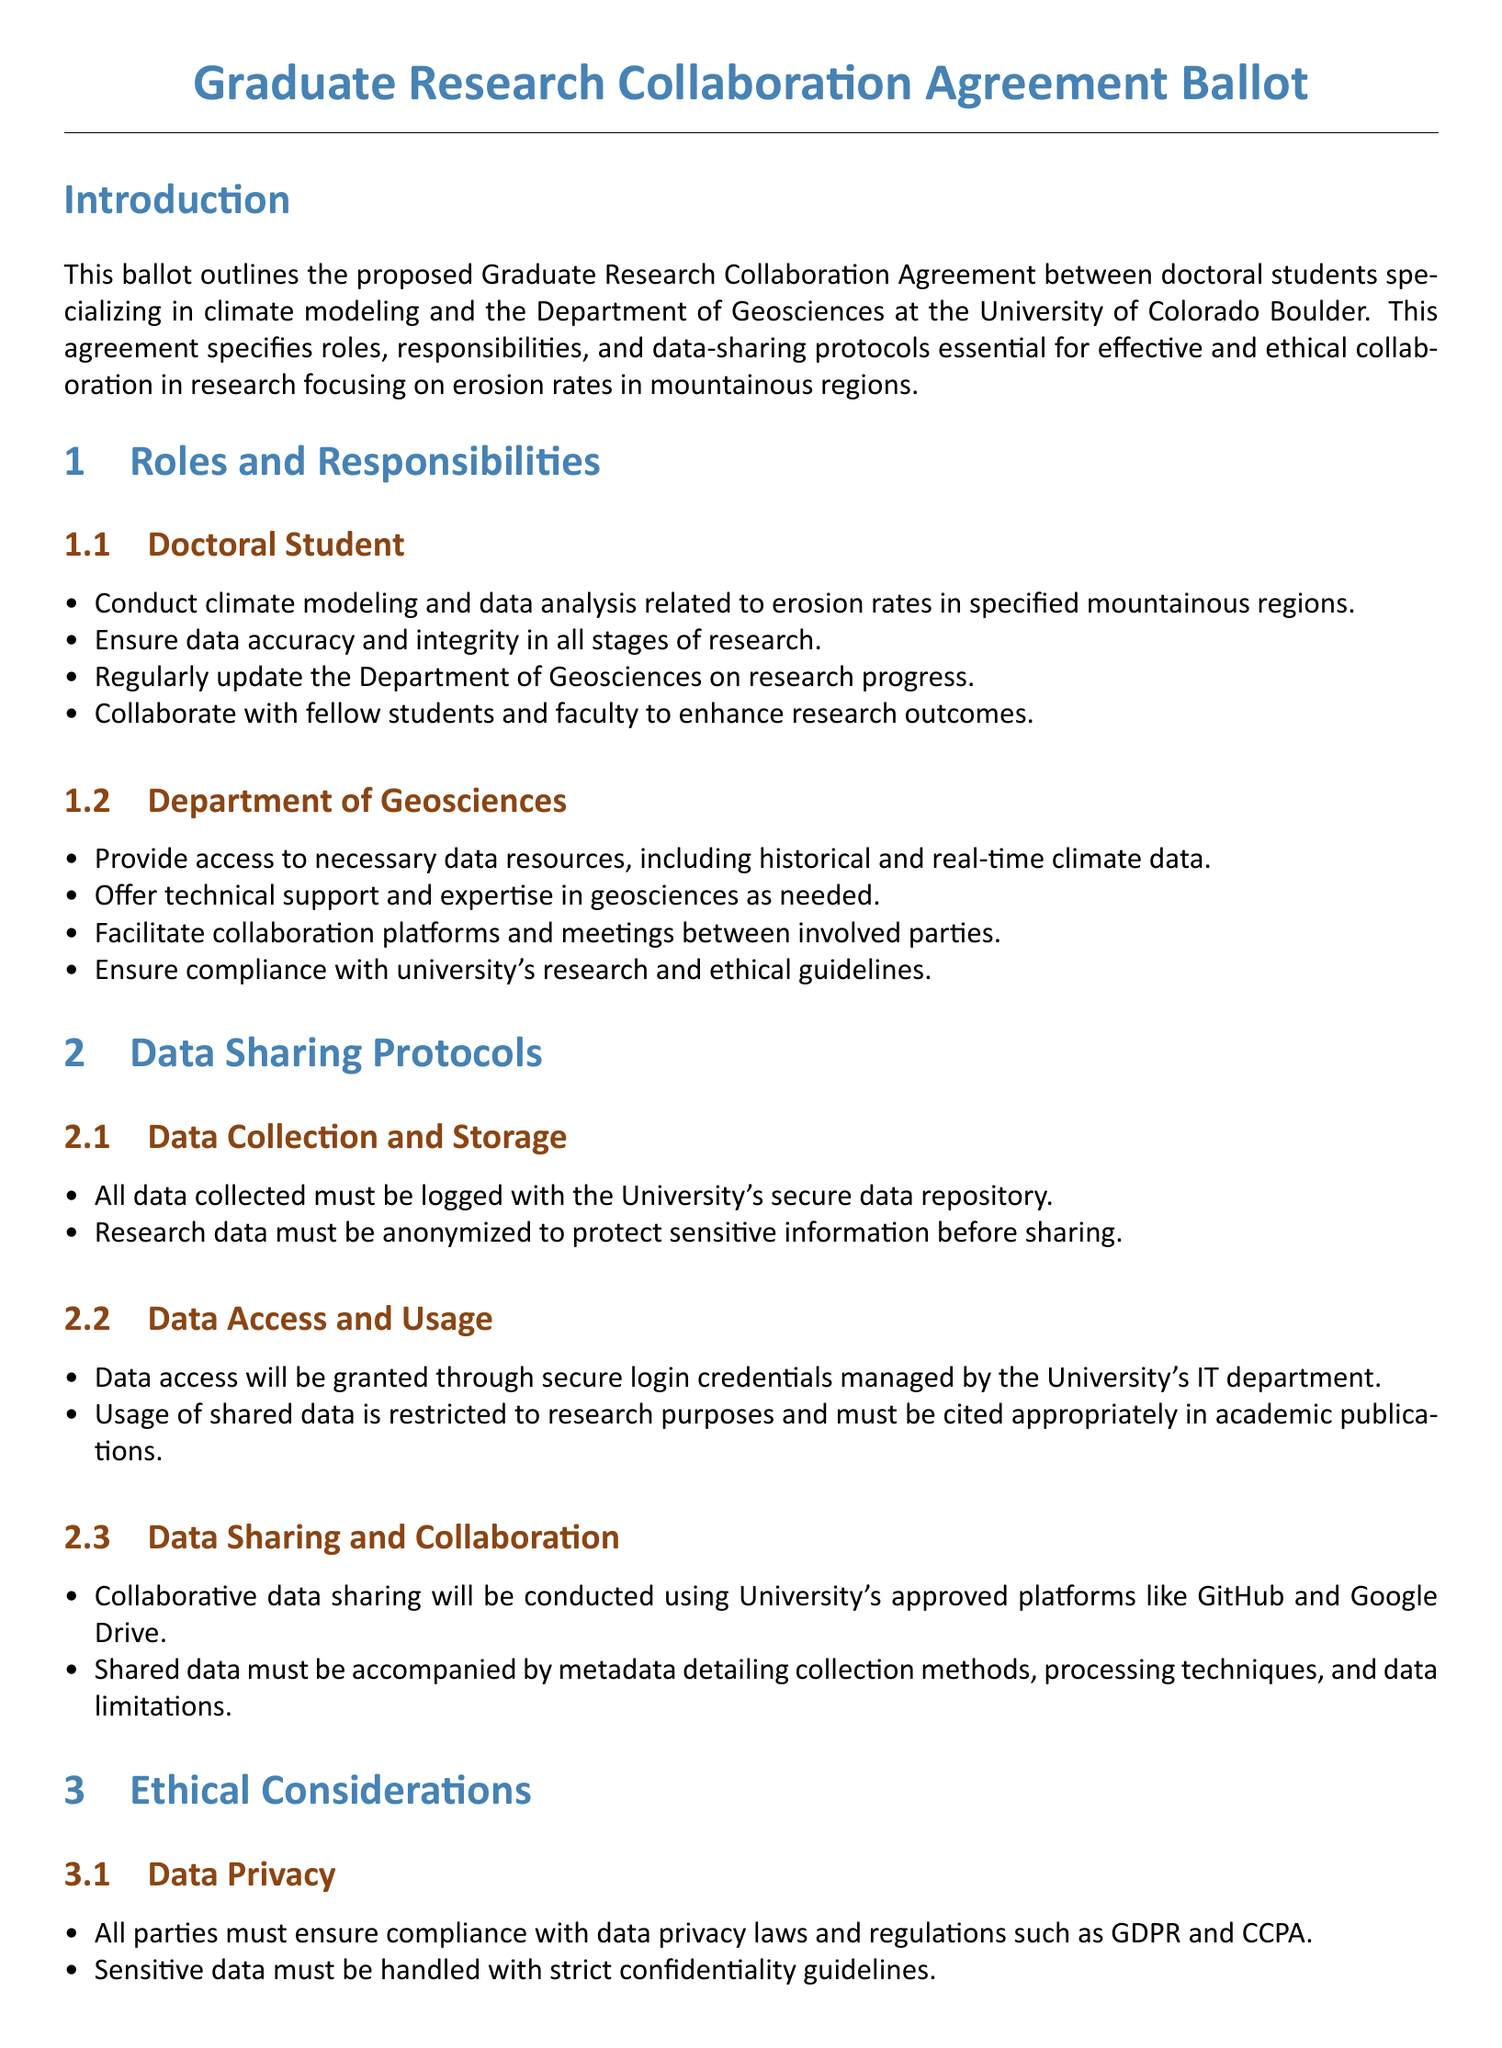What is the title of the document? The title provides the main topic of the document, which is explicitly stated as "Graduate Research Collaboration Agreement Ballot."
Answer: Graduate Research Collaboration Agreement Ballot Who are the parties involved in the collaboration? The document specifies the parties as doctoral students specializing in climate modeling and the Department of Geosciences.
Answer: Doctoral students and the Department of Geosciences What is one responsibility of the doctoral student? The document lists several responsibilities, with one being to conduct climate modeling and data analysis related to erosion rates.
Answer: Conduct climate modeling and data analysis How must the research data be handled before sharing? The document states that research data must be anonymized to protect sensitive information before it is shared.
Answer: Anonymized What platforms are approved for data sharing? The document mentions approved platforms for collaboration, specifically citing GitHub and Google Drive for data sharing.
Answer: GitHub and Google Drive What must be included with shared data? The document specifies that shared data must be accompanied by metadata that details various aspects related to the data collection and processing.
Answer: Metadata What guidelines must be followed to ensure data privacy? The document emphasizes compliance with data privacy laws and regulations such as GDPR and CCPA to ensure the protection of sensitive data.
Answer: GDPR and CCPA What voting options are provided in the ballot? The document clearly outlines the voting options available, which are to approve, disapprove, or abstain from the agreement.
Answer: Approve, Disapprove, Abstain Who is responsible for granting data access? The document indicates that data access will be managed by the University's IT department, who will handle the secure login credentials.
Answer: University's IT department 